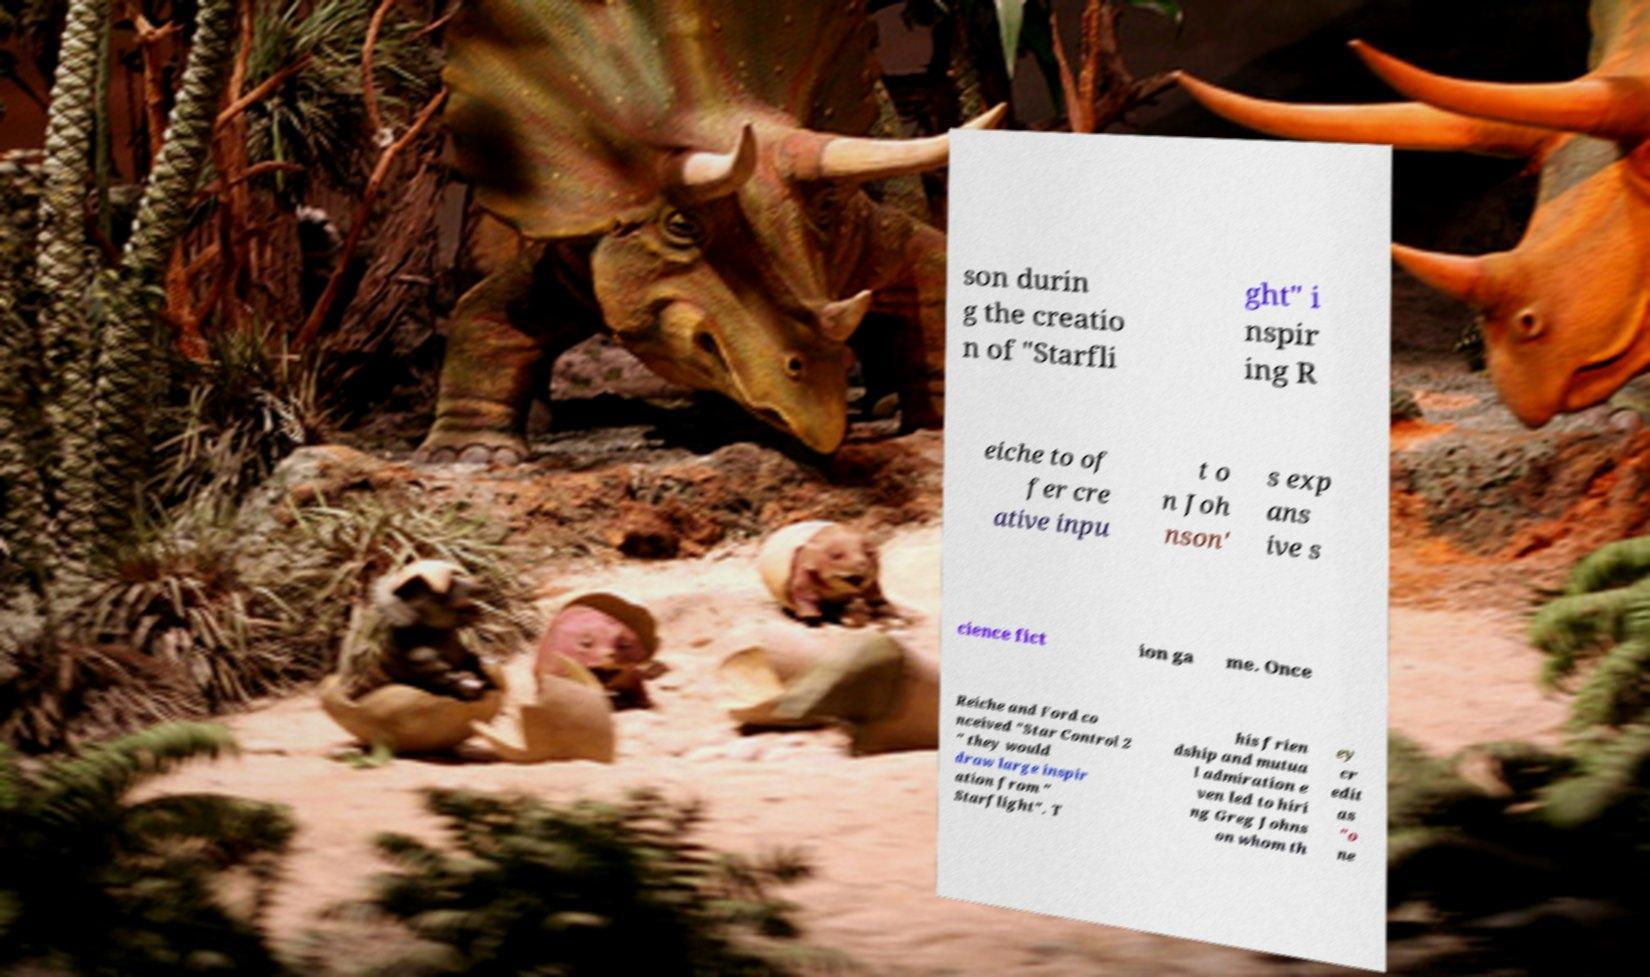Please identify and transcribe the text found in this image. son durin g the creatio n of "Starfli ght" i nspir ing R eiche to of fer cre ative inpu t o n Joh nson' s exp ans ive s cience fict ion ga me. Once Reiche and Ford co nceived "Star Control 2 " they would draw large inspir ation from " Starflight". T his frien dship and mutua l admiration e ven led to hiri ng Greg Johns on whom th ey cr edit as "o ne 